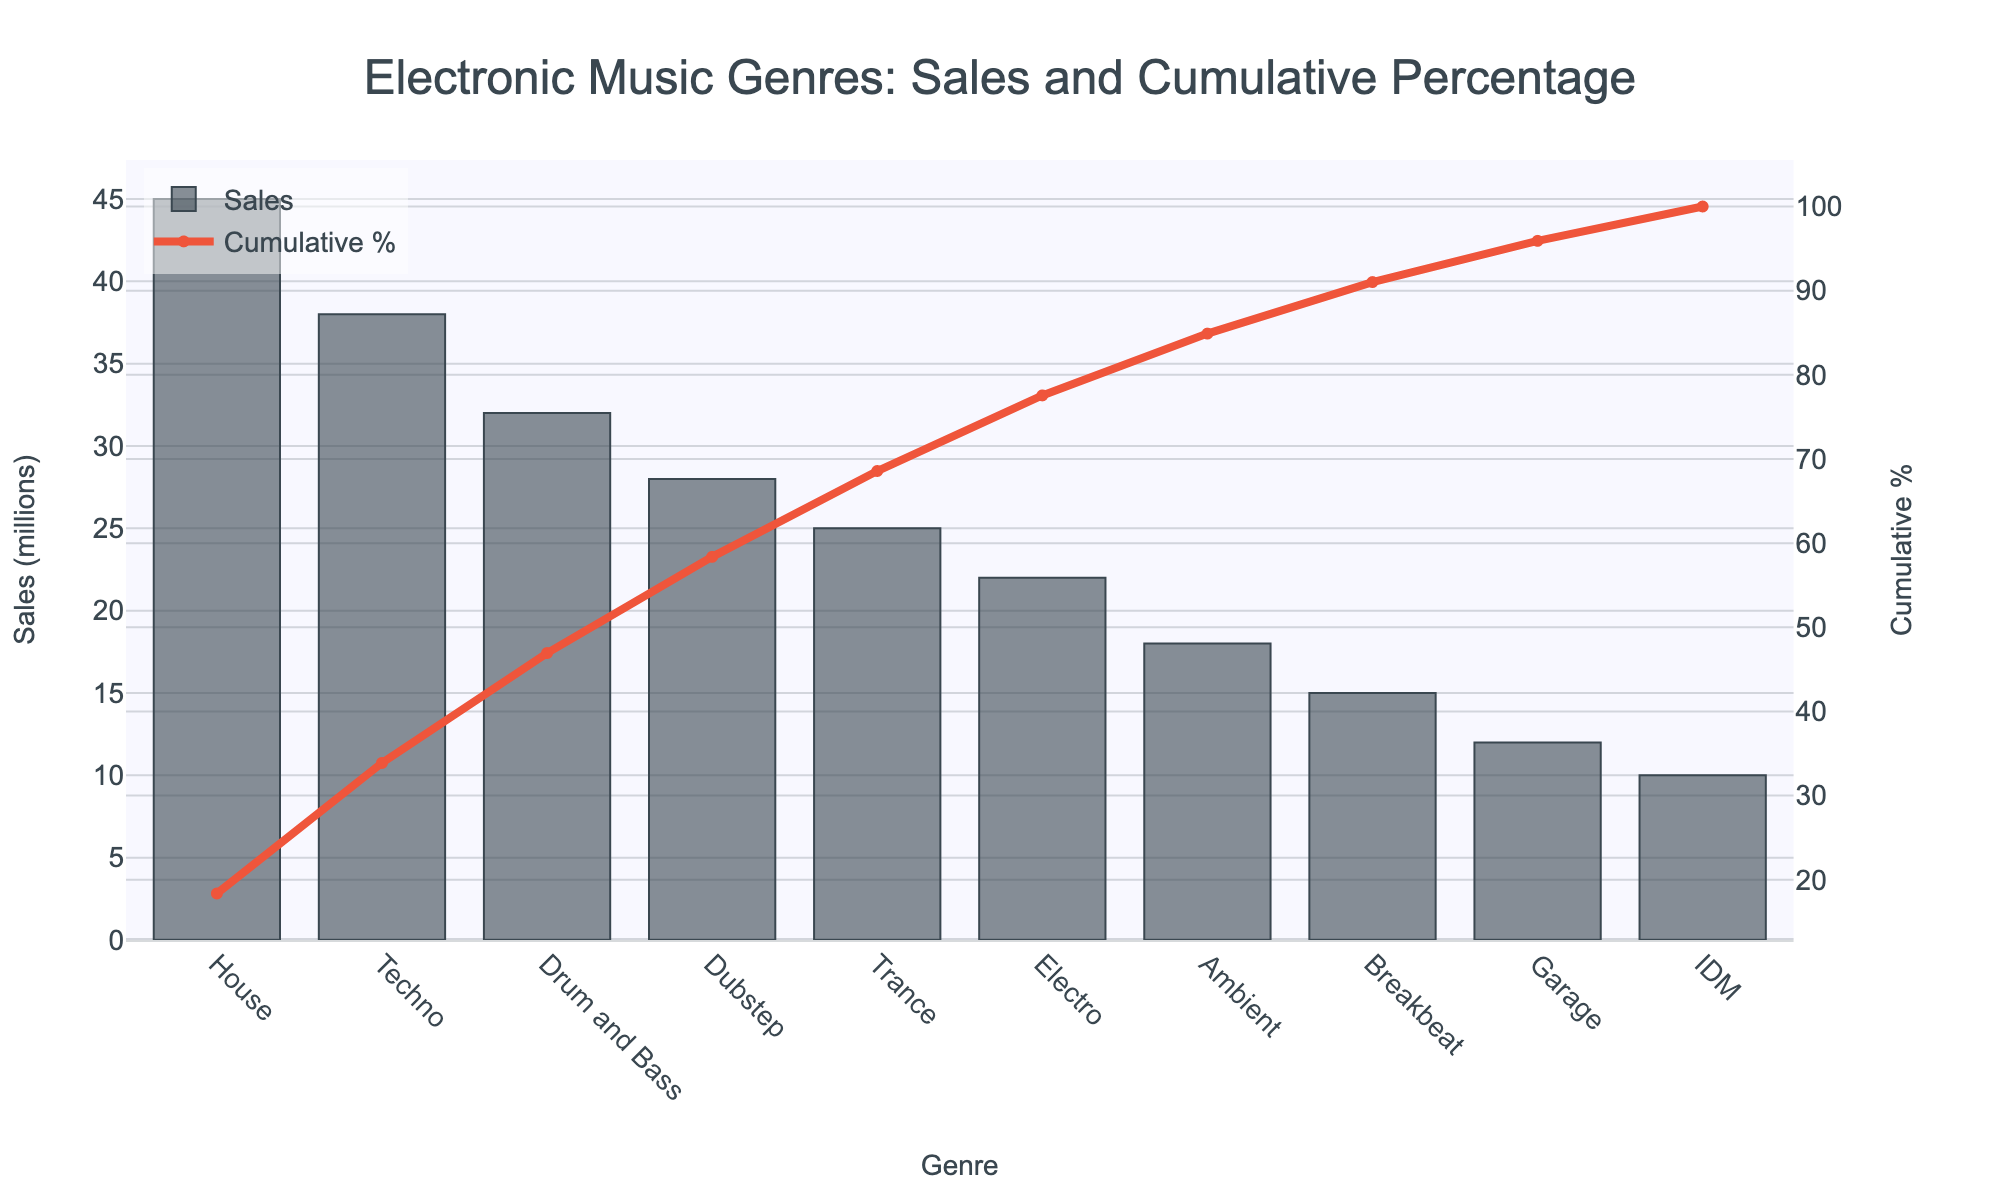What is the title of the Pareto chart? The title of a chart is usually directly displayed at the top in larger or bold font. Looking at the top of the chart, the title reads: "Electronic Music Genres: Sales and Cumulative Percentage"
Answer: Electronic Music Genres: Sales and Cumulative Percentage Which genre has the highest sales? The bar with the highest value indicates the highest sales. Looking at the bars, the tallest one corresponds to the "House" genre.
Answer: House What is the cumulative percentage for Techno? The cumulative percentage is shown by the line on the chart. Find the point where "Techno" is on the x-axis and then check the corresponding y-axis value for the cumulative percentage line. It corresponds to about 57%.
Answer: 57% What is the total sales of Drum and Bass and Dubstep combined? Add the sales values for Drum and Bass and Dubstep. Drum and Bass has a sales value of 32 million, and Dubstep has 28 million. So, 32 + 28 = 60 million.
Answer: 60 million How many genres have sales greater than 30 million? Count the bars that exceed the 30 million mark on the y-axis. The genres are House, Techno, and Drum and Bass, which totals three genres.
Answer: 3 Which genre has the lowest sales? The shortest bar represents the genre with the lowest sales. By locating the smallest bar, it is for the genre "IDM".
Answer: IDM What percentage of total sales do Ambient and Breakbeat contribute together? First, add the sales of Ambient (18 million) and Breakbeat (15 million). That equals 33 million. Then, divide by the total sales sum (45 + 38 + 32 + 28 + 25 + 22 + 18 + 15 + 12 + 10 = 245 million) and multiply by 100 to get the percentage. 33/245 * 100 ≈ 13.47%.
Answer: 13.47% Which genres contribute to more than 75% of cumulative sales combined? Following the cumulative percentage line up to past the 75% mark and identify the corresponding genres. House, Techno, Drum and Bass, and Dubstep together reach slightly more than 75%.
Answer: House, Techno, Drum and Bass, Dubstep What is the difference between the sales of House and Electro? Subtract the sales of Electro from the sales of House. House has 45 million and Electro has 22 million. Thus, 45 - 22 = 23 million.
Answer: 23 million How many genres have a cumulative percentage less than 50%? Find the genres corresponding to the points where the cumulative percentage line meets below the 50% mark. House and Techno cumulatively reach around 50%, so the genres are House and Techno.
Answer: 2 